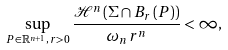Convert formula to latex. <formula><loc_0><loc_0><loc_500><loc_500>\sup _ { P \in \mathbb { R } ^ { n + 1 } , \, r > 0 } \frac { \mathcal { H } ^ { n } \left ( \Sigma \cap B _ { r } \left ( P \right ) \right ) } { \omega _ { n } r ^ { n } } < \infty ,</formula> 